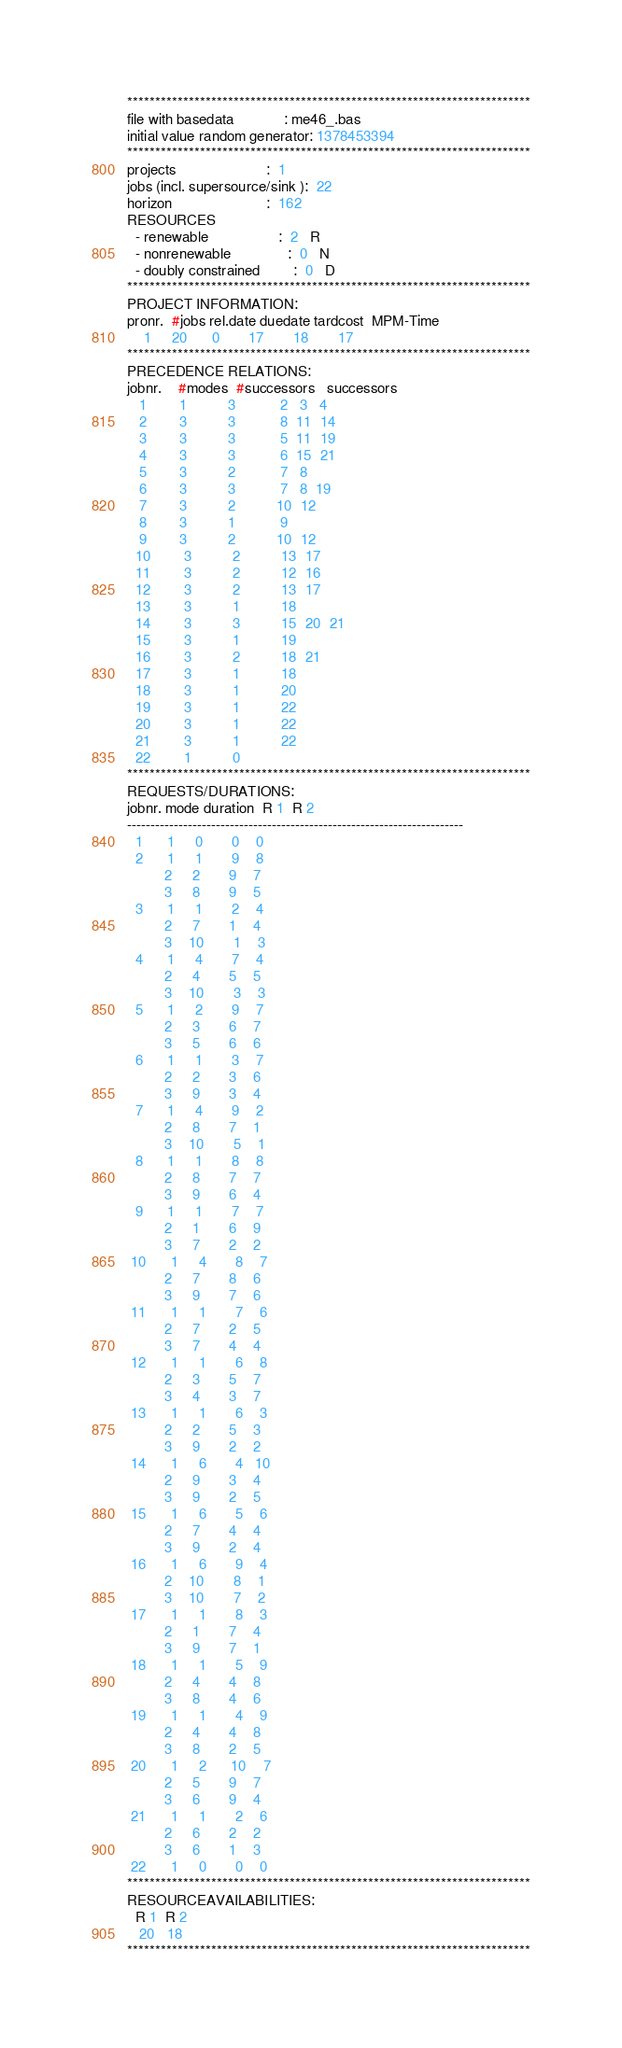<code> <loc_0><loc_0><loc_500><loc_500><_ObjectiveC_>************************************************************************
file with basedata            : me46_.bas
initial value random generator: 1378453394
************************************************************************
projects                      :  1
jobs (incl. supersource/sink ):  22
horizon                       :  162
RESOURCES
  - renewable                 :  2   R
  - nonrenewable              :  0   N
  - doubly constrained        :  0   D
************************************************************************
PROJECT INFORMATION:
pronr.  #jobs rel.date duedate tardcost  MPM-Time
    1     20      0       17       18       17
************************************************************************
PRECEDENCE RELATIONS:
jobnr.    #modes  #successors   successors
   1        1          3           2   3   4
   2        3          3           8  11  14
   3        3          3           5  11  19
   4        3          3           6  15  21
   5        3          2           7   8
   6        3          3           7   8  19
   7        3          2          10  12
   8        3          1           9
   9        3          2          10  12
  10        3          2          13  17
  11        3          2          12  16
  12        3          2          13  17
  13        3          1          18
  14        3          3          15  20  21
  15        3          1          19
  16        3          2          18  21
  17        3          1          18
  18        3          1          20
  19        3          1          22
  20        3          1          22
  21        3          1          22
  22        1          0        
************************************************************************
REQUESTS/DURATIONS:
jobnr. mode duration  R 1  R 2
------------------------------------------------------------------------
  1      1     0       0    0
  2      1     1       9    8
         2     2       9    7
         3     8       9    5
  3      1     1       2    4
         2     7       1    4
         3    10       1    3
  4      1     4       7    4
         2     4       5    5
         3    10       3    3
  5      1     2       9    7
         2     3       6    7
         3     5       6    6
  6      1     1       3    7
         2     2       3    6
         3     9       3    4
  7      1     4       9    2
         2     8       7    1
         3    10       5    1
  8      1     1       8    8
         2     8       7    7
         3     9       6    4
  9      1     1       7    7
         2     1       6    9
         3     7       2    2
 10      1     4       8    7
         2     7       8    6
         3     9       7    6
 11      1     1       7    6
         2     7       2    5
         3     7       4    4
 12      1     1       6    8
         2     3       5    7
         3     4       3    7
 13      1     1       6    3
         2     2       5    3
         3     9       2    2
 14      1     6       4   10
         2     9       3    4
         3     9       2    5
 15      1     6       5    6
         2     7       4    4
         3     9       2    4
 16      1     6       9    4
         2    10       8    1
         3    10       7    2
 17      1     1       8    3
         2     1       7    4
         3     9       7    1
 18      1     1       5    9
         2     4       4    8
         3     8       4    6
 19      1     1       4    9
         2     4       4    8
         3     8       2    5
 20      1     2      10    7
         2     5       9    7
         3     6       9    4
 21      1     1       2    6
         2     6       2    2
         3     6       1    3
 22      1     0       0    0
************************************************************************
RESOURCEAVAILABILITIES:
  R 1  R 2
   20   18
************************************************************************
</code> 